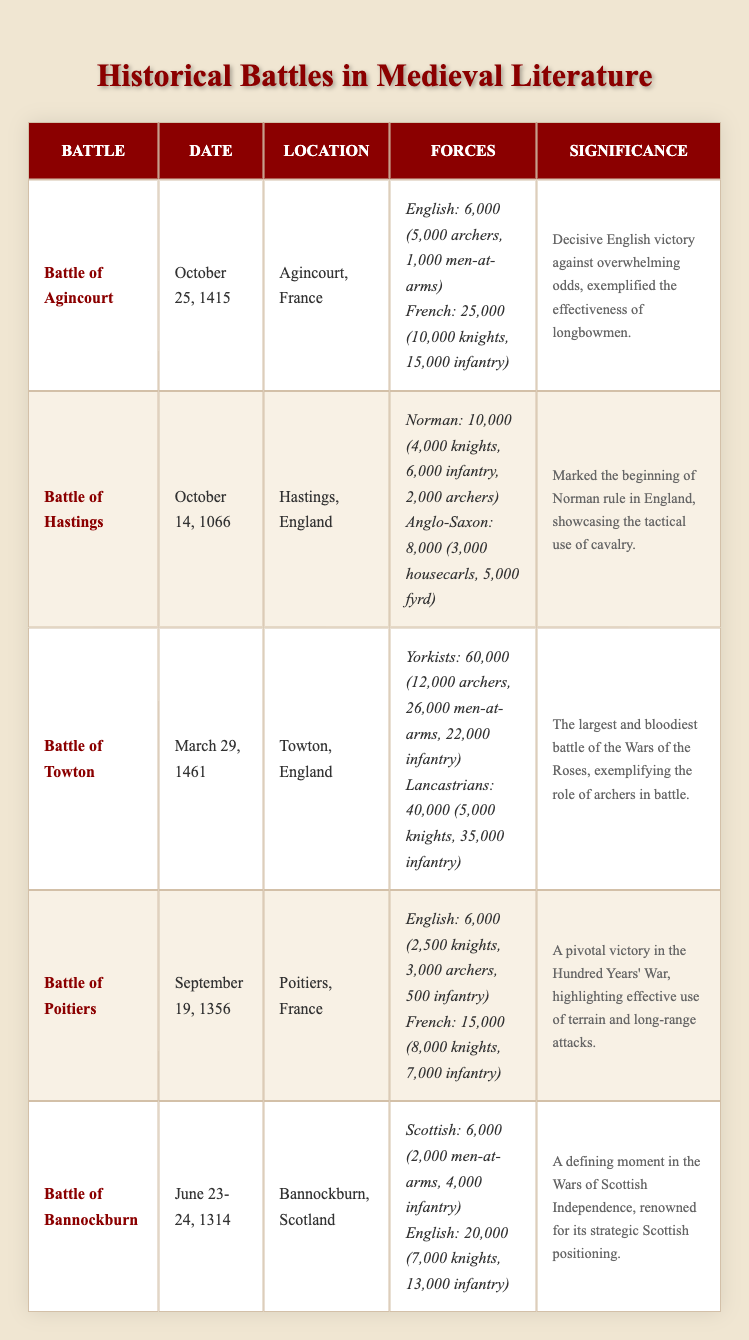What was the date of the Battle of Hastings? The date for the Battle of Hastings is listed in the table under the "Date" column next to this battle's name. It clearly states October 14, 1066.
Answer: October 14, 1066 How many total troops were involved in the Battle of Towton? To find the total number of troops in the Battle of Towton, we refer to the "total_troops" figures for both Yorkists and Lancastrians in the "Forces" column. So, 60,000 Yorkists + 40,000 Lancastrians = 100,000 total troops.
Answer: 100,000 Did the English forces in the Battle of Agincourt outnumber the French forces? Comparing the "total_troops" for both sides listed in the table, we see that the English had 6,000 and the French had 25,000. Since 6,000 is less than 25,000, the statement is false.
Answer: No Which battle had the highest number of archers, and how many were there? By reviewing the "Forces" data for each battle in the table, we find the highest number of archers during the Battle of Towton with 12,000 archers. We verify by comparing the numbers of archers across all battles.
Answer: Battle of Towton, 12,000 What was the difference in total troops between the Battle of Bannockburn and the Battle of Poitiers? First, we calculate the total troops for each battle from the table. Bannockburn has 6,000 Scottish troops and 20,000 English troops, so the total is 26,000. For Poitiers, 6,000 English and 15,000 French give us 21,000 total. The difference is 26,000 - 21,000 = 5,000.
Answer: 5,000 How many knights did the Anglo-Saxon forces have during the Battle of Hastings? In the "Forces" section for the Battle of Hastings, it specifies that the Anglo-Saxon forces had 3,000 housecarls. The category "knights" is not used for this side, only for the Norman forces. So, the answer is 0 knights.
Answer: 0 Which battle is noted for showcasing the effectiveness of longbowmen? Looking at the "Significance" column, the Battle of Agincourt explicitly states that it exemplified the effectiveness of longbowmen, making this battle the answer.
Answer: Battle of Agincourt Was there a battle that took place in Scotland? Evaluating the "Location" column reveals that the Battle of Bannockburn is the only battle listed that took place in Scotland. This confirms that the statement is true.
Answer: Yes 